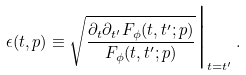<formula> <loc_0><loc_0><loc_500><loc_500>\epsilon ( t , { p } ) \equiv \sqrt { \frac { \partial _ { t } \partial _ { t ^ { \prime } } F _ { \phi } ( t , t ^ { \prime } ; { p } ) } { F _ { \phi } ( t , t ^ { \prime } ; { p } ) } } \Big | _ { t = t ^ { \prime } } \, .</formula> 